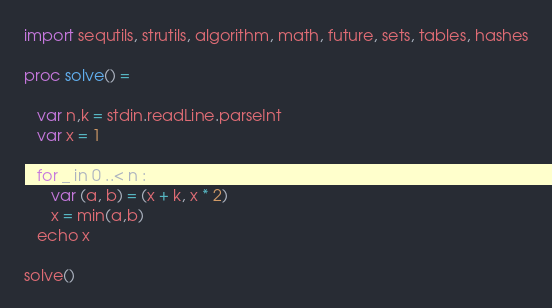<code> <loc_0><loc_0><loc_500><loc_500><_Nim_>import sequtils, strutils, algorithm, math, future, sets, tables, hashes

proc solve() =
   
   var n,k = stdin.readLine.parseInt
   var x = 1

   for _ in 0 ..< n : 
      var (a, b) = (x + k, x * 2)
      x = min(a,b)
   echo x

solve()</code> 